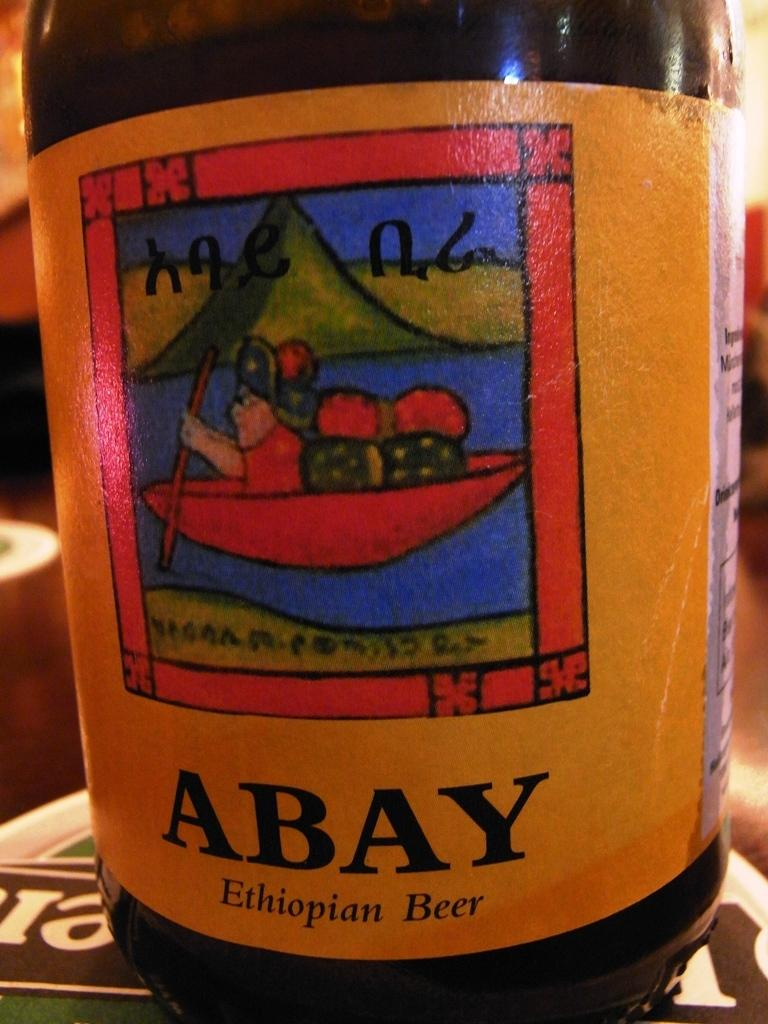Provide a one-sentence caption for the provided image. a craft beer that is made in ethiopia with a yellow label. 